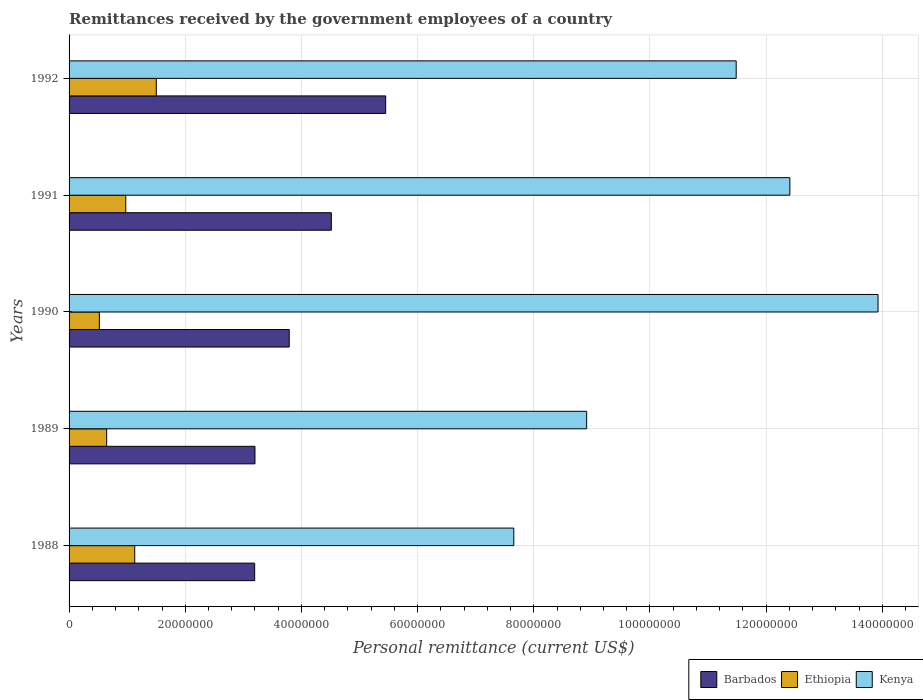How many different coloured bars are there?
Your answer should be compact. 3. How many groups of bars are there?
Offer a very short reply. 5. Are the number of bars per tick equal to the number of legend labels?
Keep it short and to the point. Yes. Are the number of bars on each tick of the Y-axis equal?
Ensure brevity in your answer.  Yes. What is the remittances received by the government employees in Ethiopia in 1990?
Offer a terse response. 5.22e+06. Across all years, what is the maximum remittances received by the government employees in Kenya?
Your response must be concise. 1.39e+08. Across all years, what is the minimum remittances received by the government employees in Barbados?
Provide a succinct answer. 3.20e+07. In which year was the remittances received by the government employees in Kenya maximum?
Offer a very short reply. 1990. In which year was the remittances received by the government employees in Barbados minimum?
Make the answer very short. 1988. What is the total remittances received by the government employees in Kenya in the graph?
Your answer should be very brief. 5.44e+08. What is the difference between the remittances received by the government employees in Barbados in 1988 and that in 1989?
Offer a terse response. -5.00e+04. What is the difference between the remittances received by the government employees in Barbados in 1991 and the remittances received by the government employees in Kenya in 1988?
Your answer should be very brief. -3.14e+07. What is the average remittances received by the government employees in Barbados per year?
Your response must be concise. 4.03e+07. In the year 1989, what is the difference between the remittances received by the government employees in Barbados and remittances received by the government employees in Ethiopia?
Offer a very short reply. 2.55e+07. In how many years, is the remittances received by the government employees in Kenya greater than 76000000 US$?
Give a very brief answer. 5. What is the ratio of the remittances received by the government employees in Kenya in 1989 to that in 1992?
Keep it short and to the point. 0.78. Is the remittances received by the government employees in Kenya in 1990 less than that in 1992?
Your answer should be compact. No. What is the difference between the highest and the second highest remittances received by the government employees in Kenya?
Offer a very short reply. 1.52e+07. What is the difference between the highest and the lowest remittances received by the government employees in Barbados?
Provide a succinct answer. 2.25e+07. In how many years, is the remittances received by the government employees in Ethiopia greater than the average remittances received by the government employees in Ethiopia taken over all years?
Keep it short and to the point. 3. What does the 3rd bar from the top in 1992 represents?
Keep it short and to the point. Barbados. What does the 3rd bar from the bottom in 1992 represents?
Your answer should be very brief. Kenya. What is the difference between two consecutive major ticks on the X-axis?
Offer a terse response. 2.00e+07. Does the graph contain any zero values?
Your answer should be very brief. No. Does the graph contain grids?
Your answer should be compact. Yes. What is the title of the graph?
Your answer should be compact. Remittances received by the government employees of a country. What is the label or title of the X-axis?
Make the answer very short. Personal remittance (current US$). What is the Personal remittance (current US$) in Barbados in 1988?
Offer a terse response. 3.20e+07. What is the Personal remittance (current US$) in Ethiopia in 1988?
Provide a succinct answer. 1.13e+07. What is the Personal remittance (current US$) in Kenya in 1988?
Your answer should be very brief. 7.66e+07. What is the Personal remittance (current US$) in Barbados in 1989?
Provide a succinct answer. 3.20e+07. What is the Personal remittance (current US$) of Ethiopia in 1989?
Your answer should be very brief. 6.47e+06. What is the Personal remittance (current US$) of Kenya in 1989?
Make the answer very short. 8.91e+07. What is the Personal remittance (current US$) of Barbados in 1990?
Offer a very short reply. 3.79e+07. What is the Personal remittance (current US$) of Ethiopia in 1990?
Provide a short and direct response. 5.22e+06. What is the Personal remittance (current US$) of Kenya in 1990?
Your answer should be very brief. 1.39e+08. What is the Personal remittance (current US$) in Barbados in 1991?
Your response must be concise. 4.52e+07. What is the Personal remittance (current US$) of Ethiopia in 1991?
Ensure brevity in your answer.  9.76e+06. What is the Personal remittance (current US$) in Kenya in 1991?
Provide a succinct answer. 1.24e+08. What is the Personal remittance (current US$) of Barbados in 1992?
Your answer should be compact. 5.45e+07. What is the Personal remittance (current US$) in Ethiopia in 1992?
Keep it short and to the point. 1.50e+07. What is the Personal remittance (current US$) of Kenya in 1992?
Offer a very short reply. 1.15e+08. Across all years, what is the maximum Personal remittance (current US$) in Barbados?
Your answer should be compact. 5.45e+07. Across all years, what is the maximum Personal remittance (current US$) in Ethiopia?
Provide a short and direct response. 1.50e+07. Across all years, what is the maximum Personal remittance (current US$) in Kenya?
Your response must be concise. 1.39e+08. Across all years, what is the minimum Personal remittance (current US$) of Barbados?
Provide a short and direct response. 3.20e+07. Across all years, what is the minimum Personal remittance (current US$) in Ethiopia?
Keep it short and to the point. 5.22e+06. Across all years, what is the minimum Personal remittance (current US$) of Kenya?
Your response must be concise. 7.66e+07. What is the total Personal remittance (current US$) in Barbados in the graph?
Your answer should be compact. 2.02e+08. What is the total Personal remittance (current US$) in Ethiopia in the graph?
Give a very brief answer. 4.78e+07. What is the total Personal remittance (current US$) in Kenya in the graph?
Offer a terse response. 5.44e+08. What is the difference between the Personal remittance (current US$) in Barbados in 1988 and that in 1989?
Offer a terse response. -5.00e+04. What is the difference between the Personal remittance (current US$) in Ethiopia in 1988 and that in 1989?
Make the answer very short. 4.83e+06. What is the difference between the Personal remittance (current US$) of Kenya in 1988 and that in 1989?
Keep it short and to the point. -1.25e+07. What is the difference between the Personal remittance (current US$) in Barbados in 1988 and that in 1990?
Provide a succinct answer. -5.95e+06. What is the difference between the Personal remittance (current US$) of Ethiopia in 1988 and that in 1990?
Offer a very short reply. 6.09e+06. What is the difference between the Personal remittance (current US$) in Kenya in 1988 and that in 1990?
Keep it short and to the point. -6.27e+07. What is the difference between the Personal remittance (current US$) of Barbados in 1988 and that in 1991?
Make the answer very short. -1.32e+07. What is the difference between the Personal remittance (current US$) in Ethiopia in 1988 and that in 1991?
Ensure brevity in your answer.  1.55e+06. What is the difference between the Personal remittance (current US$) of Kenya in 1988 and that in 1991?
Make the answer very short. -4.75e+07. What is the difference between the Personal remittance (current US$) of Barbados in 1988 and that in 1992?
Offer a very short reply. -2.25e+07. What is the difference between the Personal remittance (current US$) of Ethiopia in 1988 and that in 1992?
Make the answer very short. -3.71e+06. What is the difference between the Personal remittance (current US$) in Kenya in 1988 and that in 1992?
Your answer should be compact. -3.83e+07. What is the difference between the Personal remittance (current US$) in Barbados in 1989 and that in 1990?
Offer a very short reply. -5.90e+06. What is the difference between the Personal remittance (current US$) of Ethiopia in 1989 and that in 1990?
Offer a terse response. 1.26e+06. What is the difference between the Personal remittance (current US$) in Kenya in 1989 and that in 1990?
Make the answer very short. -5.02e+07. What is the difference between the Personal remittance (current US$) of Barbados in 1989 and that in 1991?
Your response must be concise. -1.32e+07. What is the difference between the Personal remittance (current US$) in Ethiopia in 1989 and that in 1991?
Make the answer very short. -3.29e+06. What is the difference between the Personal remittance (current US$) in Kenya in 1989 and that in 1991?
Your answer should be very brief. -3.50e+07. What is the difference between the Personal remittance (current US$) of Barbados in 1989 and that in 1992?
Your response must be concise. -2.25e+07. What is the difference between the Personal remittance (current US$) of Ethiopia in 1989 and that in 1992?
Make the answer very short. -8.55e+06. What is the difference between the Personal remittance (current US$) of Kenya in 1989 and that in 1992?
Offer a very short reply. -2.57e+07. What is the difference between the Personal remittance (current US$) in Barbados in 1990 and that in 1991?
Your answer should be compact. -7.25e+06. What is the difference between the Personal remittance (current US$) in Ethiopia in 1990 and that in 1991?
Offer a very short reply. -4.54e+06. What is the difference between the Personal remittance (current US$) in Kenya in 1990 and that in 1991?
Your response must be concise. 1.52e+07. What is the difference between the Personal remittance (current US$) of Barbados in 1990 and that in 1992?
Provide a short and direct response. -1.66e+07. What is the difference between the Personal remittance (current US$) in Ethiopia in 1990 and that in 1992?
Ensure brevity in your answer.  -9.80e+06. What is the difference between the Personal remittance (current US$) of Kenya in 1990 and that in 1992?
Provide a succinct answer. 2.44e+07. What is the difference between the Personal remittance (current US$) in Barbados in 1991 and that in 1992?
Offer a very short reply. -9.35e+06. What is the difference between the Personal remittance (current US$) in Ethiopia in 1991 and that in 1992?
Offer a terse response. -5.26e+06. What is the difference between the Personal remittance (current US$) of Kenya in 1991 and that in 1992?
Keep it short and to the point. 9.24e+06. What is the difference between the Personal remittance (current US$) in Barbados in 1988 and the Personal remittance (current US$) in Ethiopia in 1989?
Give a very brief answer. 2.55e+07. What is the difference between the Personal remittance (current US$) of Barbados in 1988 and the Personal remittance (current US$) of Kenya in 1989?
Your answer should be very brief. -5.71e+07. What is the difference between the Personal remittance (current US$) of Ethiopia in 1988 and the Personal remittance (current US$) of Kenya in 1989?
Keep it short and to the point. -7.78e+07. What is the difference between the Personal remittance (current US$) of Barbados in 1988 and the Personal remittance (current US$) of Ethiopia in 1990?
Your response must be concise. 2.67e+07. What is the difference between the Personal remittance (current US$) of Barbados in 1988 and the Personal remittance (current US$) of Kenya in 1990?
Keep it short and to the point. -1.07e+08. What is the difference between the Personal remittance (current US$) in Ethiopia in 1988 and the Personal remittance (current US$) in Kenya in 1990?
Keep it short and to the point. -1.28e+08. What is the difference between the Personal remittance (current US$) in Barbados in 1988 and the Personal remittance (current US$) in Ethiopia in 1991?
Your response must be concise. 2.22e+07. What is the difference between the Personal remittance (current US$) of Barbados in 1988 and the Personal remittance (current US$) of Kenya in 1991?
Ensure brevity in your answer.  -9.21e+07. What is the difference between the Personal remittance (current US$) in Ethiopia in 1988 and the Personal remittance (current US$) in Kenya in 1991?
Make the answer very short. -1.13e+08. What is the difference between the Personal remittance (current US$) of Barbados in 1988 and the Personal remittance (current US$) of Ethiopia in 1992?
Make the answer very short. 1.69e+07. What is the difference between the Personal remittance (current US$) of Barbados in 1988 and the Personal remittance (current US$) of Kenya in 1992?
Make the answer very short. -8.29e+07. What is the difference between the Personal remittance (current US$) in Ethiopia in 1988 and the Personal remittance (current US$) in Kenya in 1992?
Offer a very short reply. -1.04e+08. What is the difference between the Personal remittance (current US$) in Barbados in 1989 and the Personal remittance (current US$) in Ethiopia in 1990?
Offer a very short reply. 2.68e+07. What is the difference between the Personal remittance (current US$) of Barbados in 1989 and the Personal remittance (current US$) of Kenya in 1990?
Your answer should be very brief. -1.07e+08. What is the difference between the Personal remittance (current US$) in Ethiopia in 1989 and the Personal remittance (current US$) in Kenya in 1990?
Your answer should be compact. -1.33e+08. What is the difference between the Personal remittance (current US$) in Barbados in 1989 and the Personal remittance (current US$) in Ethiopia in 1991?
Provide a short and direct response. 2.22e+07. What is the difference between the Personal remittance (current US$) in Barbados in 1989 and the Personal remittance (current US$) in Kenya in 1991?
Your response must be concise. -9.21e+07. What is the difference between the Personal remittance (current US$) of Ethiopia in 1989 and the Personal remittance (current US$) of Kenya in 1991?
Give a very brief answer. -1.18e+08. What is the difference between the Personal remittance (current US$) in Barbados in 1989 and the Personal remittance (current US$) in Ethiopia in 1992?
Ensure brevity in your answer.  1.70e+07. What is the difference between the Personal remittance (current US$) of Barbados in 1989 and the Personal remittance (current US$) of Kenya in 1992?
Your response must be concise. -8.28e+07. What is the difference between the Personal remittance (current US$) of Ethiopia in 1989 and the Personal remittance (current US$) of Kenya in 1992?
Your answer should be very brief. -1.08e+08. What is the difference between the Personal remittance (current US$) of Barbados in 1990 and the Personal remittance (current US$) of Ethiopia in 1991?
Offer a terse response. 2.81e+07. What is the difference between the Personal remittance (current US$) of Barbados in 1990 and the Personal remittance (current US$) of Kenya in 1991?
Make the answer very short. -8.62e+07. What is the difference between the Personal remittance (current US$) in Ethiopia in 1990 and the Personal remittance (current US$) in Kenya in 1991?
Your response must be concise. -1.19e+08. What is the difference between the Personal remittance (current US$) of Barbados in 1990 and the Personal remittance (current US$) of Ethiopia in 1992?
Your answer should be very brief. 2.29e+07. What is the difference between the Personal remittance (current US$) of Barbados in 1990 and the Personal remittance (current US$) of Kenya in 1992?
Your response must be concise. -7.69e+07. What is the difference between the Personal remittance (current US$) of Ethiopia in 1990 and the Personal remittance (current US$) of Kenya in 1992?
Give a very brief answer. -1.10e+08. What is the difference between the Personal remittance (current US$) of Barbados in 1991 and the Personal remittance (current US$) of Ethiopia in 1992?
Offer a terse response. 3.01e+07. What is the difference between the Personal remittance (current US$) of Barbados in 1991 and the Personal remittance (current US$) of Kenya in 1992?
Your answer should be compact. -6.97e+07. What is the difference between the Personal remittance (current US$) in Ethiopia in 1991 and the Personal remittance (current US$) in Kenya in 1992?
Keep it short and to the point. -1.05e+08. What is the average Personal remittance (current US$) of Barbados per year?
Your answer should be compact. 4.03e+07. What is the average Personal remittance (current US$) of Ethiopia per year?
Your response must be concise. 9.55e+06. What is the average Personal remittance (current US$) in Kenya per year?
Ensure brevity in your answer.  1.09e+08. In the year 1988, what is the difference between the Personal remittance (current US$) in Barbados and Personal remittance (current US$) in Ethiopia?
Provide a succinct answer. 2.06e+07. In the year 1988, what is the difference between the Personal remittance (current US$) of Barbados and Personal remittance (current US$) of Kenya?
Offer a very short reply. -4.46e+07. In the year 1988, what is the difference between the Personal remittance (current US$) of Ethiopia and Personal remittance (current US$) of Kenya?
Your answer should be very brief. -6.53e+07. In the year 1989, what is the difference between the Personal remittance (current US$) of Barbados and Personal remittance (current US$) of Ethiopia?
Your answer should be very brief. 2.55e+07. In the year 1989, what is the difference between the Personal remittance (current US$) in Barbados and Personal remittance (current US$) in Kenya?
Provide a succinct answer. -5.71e+07. In the year 1989, what is the difference between the Personal remittance (current US$) in Ethiopia and Personal remittance (current US$) in Kenya?
Provide a succinct answer. -8.26e+07. In the year 1990, what is the difference between the Personal remittance (current US$) of Barbados and Personal remittance (current US$) of Ethiopia?
Offer a terse response. 3.27e+07. In the year 1990, what is the difference between the Personal remittance (current US$) of Barbados and Personal remittance (current US$) of Kenya?
Your response must be concise. -1.01e+08. In the year 1990, what is the difference between the Personal remittance (current US$) in Ethiopia and Personal remittance (current US$) in Kenya?
Your answer should be very brief. -1.34e+08. In the year 1991, what is the difference between the Personal remittance (current US$) in Barbados and Personal remittance (current US$) in Ethiopia?
Your response must be concise. 3.54e+07. In the year 1991, what is the difference between the Personal remittance (current US$) of Barbados and Personal remittance (current US$) of Kenya?
Your answer should be very brief. -7.89e+07. In the year 1991, what is the difference between the Personal remittance (current US$) of Ethiopia and Personal remittance (current US$) of Kenya?
Your response must be concise. -1.14e+08. In the year 1992, what is the difference between the Personal remittance (current US$) in Barbados and Personal remittance (current US$) in Ethiopia?
Your answer should be very brief. 3.95e+07. In the year 1992, what is the difference between the Personal remittance (current US$) of Barbados and Personal remittance (current US$) of Kenya?
Provide a succinct answer. -6.03e+07. In the year 1992, what is the difference between the Personal remittance (current US$) in Ethiopia and Personal remittance (current US$) in Kenya?
Your answer should be very brief. -9.98e+07. What is the ratio of the Personal remittance (current US$) in Ethiopia in 1988 to that in 1989?
Offer a terse response. 1.75. What is the ratio of the Personal remittance (current US$) of Kenya in 1988 to that in 1989?
Your response must be concise. 0.86. What is the ratio of the Personal remittance (current US$) in Barbados in 1988 to that in 1990?
Your response must be concise. 0.84. What is the ratio of the Personal remittance (current US$) of Ethiopia in 1988 to that in 1990?
Your answer should be very brief. 2.17. What is the ratio of the Personal remittance (current US$) of Kenya in 1988 to that in 1990?
Offer a terse response. 0.55. What is the ratio of the Personal remittance (current US$) in Barbados in 1988 to that in 1991?
Provide a short and direct response. 0.71. What is the ratio of the Personal remittance (current US$) in Ethiopia in 1988 to that in 1991?
Your response must be concise. 1.16. What is the ratio of the Personal remittance (current US$) in Kenya in 1988 to that in 1991?
Offer a terse response. 0.62. What is the ratio of the Personal remittance (current US$) of Barbados in 1988 to that in 1992?
Your response must be concise. 0.59. What is the ratio of the Personal remittance (current US$) of Ethiopia in 1988 to that in 1992?
Keep it short and to the point. 0.75. What is the ratio of the Personal remittance (current US$) in Barbados in 1989 to that in 1990?
Keep it short and to the point. 0.84. What is the ratio of the Personal remittance (current US$) in Ethiopia in 1989 to that in 1990?
Provide a short and direct response. 1.24. What is the ratio of the Personal remittance (current US$) of Kenya in 1989 to that in 1990?
Your answer should be very brief. 0.64. What is the ratio of the Personal remittance (current US$) in Barbados in 1989 to that in 1991?
Provide a short and direct response. 0.71. What is the ratio of the Personal remittance (current US$) in Ethiopia in 1989 to that in 1991?
Your answer should be compact. 0.66. What is the ratio of the Personal remittance (current US$) of Kenya in 1989 to that in 1991?
Your response must be concise. 0.72. What is the ratio of the Personal remittance (current US$) in Barbados in 1989 to that in 1992?
Your answer should be compact. 0.59. What is the ratio of the Personal remittance (current US$) in Ethiopia in 1989 to that in 1992?
Keep it short and to the point. 0.43. What is the ratio of the Personal remittance (current US$) in Kenya in 1989 to that in 1992?
Offer a terse response. 0.78. What is the ratio of the Personal remittance (current US$) of Barbados in 1990 to that in 1991?
Provide a succinct answer. 0.84. What is the ratio of the Personal remittance (current US$) of Ethiopia in 1990 to that in 1991?
Provide a short and direct response. 0.53. What is the ratio of the Personal remittance (current US$) in Kenya in 1990 to that in 1991?
Your answer should be compact. 1.12. What is the ratio of the Personal remittance (current US$) in Barbados in 1990 to that in 1992?
Offer a terse response. 0.7. What is the ratio of the Personal remittance (current US$) of Ethiopia in 1990 to that in 1992?
Make the answer very short. 0.35. What is the ratio of the Personal remittance (current US$) of Kenya in 1990 to that in 1992?
Your answer should be very brief. 1.21. What is the ratio of the Personal remittance (current US$) in Barbados in 1991 to that in 1992?
Make the answer very short. 0.83. What is the ratio of the Personal remittance (current US$) of Ethiopia in 1991 to that in 1992?
Ensure brevity in your answer.  0.65. What is the ratio of the Personal remittance (current US$) in Kenya in 1991 to that in 1992?
Keep it short and to the point. 1.08. What is the difference between the highest and the second highest Personal remittance (current US$) in Barbados?
Your response must be concise. 9.35e+06. What is the difference between the highest and the second highest Personal remittance (current US$) of Ethiopia?
Your answer should be compact. 3.71e+06. What is the difference between the highest and the second highest Personal remittance (current US$) in Kenya?
Your answer should be very brief. 1.52e+07. What is the difference between the highest and the lowest Personal remittance (current US$) in Barbados?
Ensure brevity in your answer.  2.25e+07. What is the difference between the highest and the lowest Personal remittance (current US$) in Ethiopia?
Make the answer very short. 9.80e+06. What is the difference between the highest and the lowest Personal remittance (current US$) of Kenya?
Make the answer very short. 6.27e+07. 